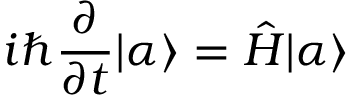<formula> <loc_0><loc_0><loc_500><loc_500>i \hbar { \frac { \partial } { \partial t } } | \alpha \rangle = { \hat { H } } | \alpha \rangle</formula> 